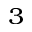<formula> <loc_0><loc_0><loc_500><loc_500>^ { 3 }</formula> 